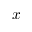Convert formula to latex. <formula><loc_0><loc_0><loc_500><loc_500>x</formula> 